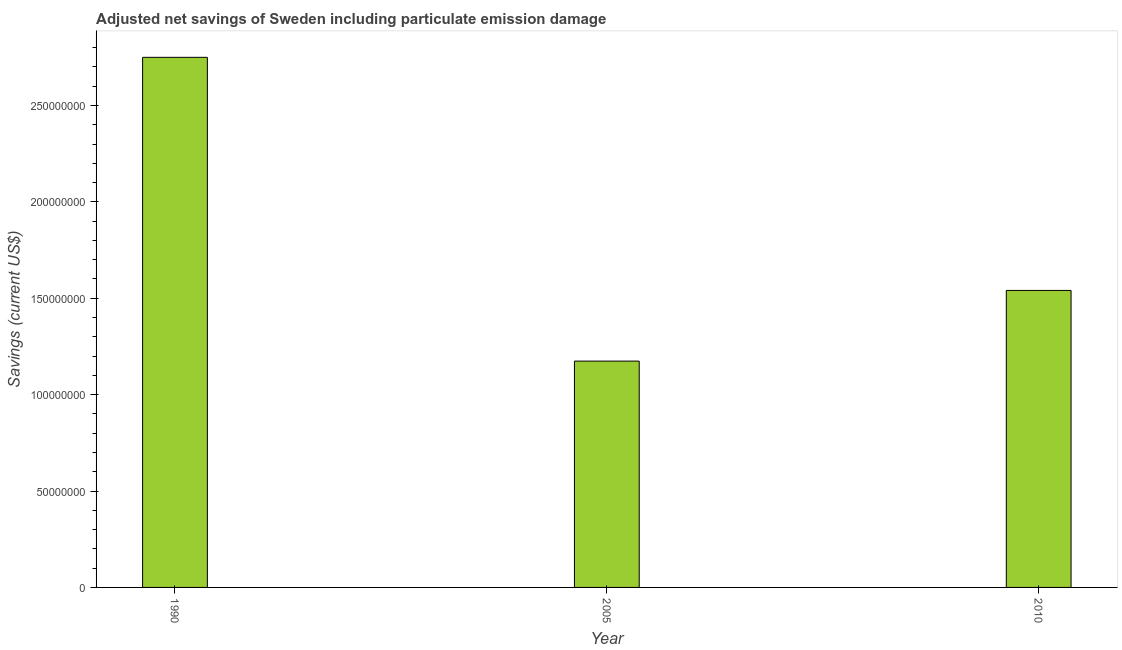Does the graph contain any zero values?
Ensure brevity in your answer.  No. What is the title of the graph?
Give a very brief answer. Adjusted net savings of Sweden including particulate emission damage. What is the label or title of the Y-axis?
Your response must be concise. Savings (current US$). What is the adjusted net savings in 2005?
Make the answer very short. 1.17e+08. Across all years, what is the maximum adjusted net savings?
Provide a succinct answer. 2.75e+08. Across all years, what is the minimum adjusted net savings?
Your response must be concise. 1.17e+08. In which year was the adjusted net savings minimum?
Ensure brevity in your answer.  2005. What is the sum of the adjusted net savings?
Provide a succinct answer. 5.46e+08. What is the difference between the adjusted net savings in 1990 and 2005?
Offer a terse response. 1.58e+08. What is the average adjusted net savings per year?
Make the answer very short. 1.82e+08. What is the median adjusted net savings?
Offer a terse response. 1.54e+08. In how many years, is the adjusted net savings greater than 220000000 US$?
Give a very brief answer. 1. Do a majority of the years between 2010 and 2005 (inclusive) have adjusted net savings greater than 170000000 US$?
Provide a short and direct response. No. What is the ratio of the adjusted net savings in 1990 to that in 2005?
Keep it short and to the point. 2.34. Is the difference between the adjusted net savings in 2005 and 2010 greater than the difference between any two years?
Provide a succinct answer. No. What is the difference between the highest and the second highest adjusted net savings?
Provide a short and direct response. 1.21e+08. Is the sum of the adjusted net savings in 2005 and 2010 greater than the maximum adjusted net savings across all years?
Make the answer very short. No. What is the difference between the highest and the lowest adjusted net savings?
Ensure brevity in your answer.  1.58e+08. In how many years, is the adjusted net savings greater than the average adjusted net savings taken over all years?
Offer a terse response. 1. How many bars are there?
Keep it short and to the point. 3. How many years are there in the graph?
Ensure brevity in your answer.  3. What is the difference between two consecutive major ticks on the Y-axis?
Your answer should be very brief. 5.00e+07. Are the values on the major ticks of Y-axis written in scientific E-notation?
Keep it short and to the point. No. What is the Savings (current US$) of 1990?
Your answer should be very brief. 2.75e+08. What is the Savings (current US$) in 2005?
Your response must be concise. 1.17e+08. What is the Savings (current US$) of 2010?
Your answer should be compact. 1.54e+08. What is the difference between the Savings (current US$) in 1990 and 2005?
Provide a succinct answer. 1.58e+08. What is the difference between the Savings (current US$) in 1990 and 2010?
Make the answer very short. 1.21e+08. What is the difference between the Savings (current US$) in 2005 and 2010?
Offer a terse response. -3.67e+07. What is the ratio of the Savings (current US$) in 1990 to that in 2005?
Your answer should be compact. 2.34. What is the ratio of the Savings (current US$) in 1990 to that in 2010?
Give a very brief answer. 1.78. What is the ratio of the Savings (current US$) in 2005 to that in 2010?
Give a very brief answer. 0.76. 